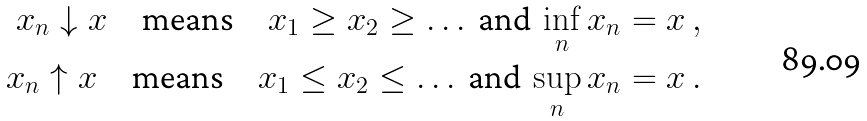Convert formula to latex. <formula><loc_0><loc_0><loc_500><loc_500>x _ { n } \downarrow x \quad \text {means} \quad x _ { 1 } \geq x _ { 2 } \geq \dots \text {  and } \inf _ { n } x _ { n } = x \, , \\ x _ { n } \uparrow x \quad \text {means} \quad x _ { 1 } \leq x _ { 2 } \leq \dots \text {  and } \sup _ { n } x _ { n } = x \, .</formula> 